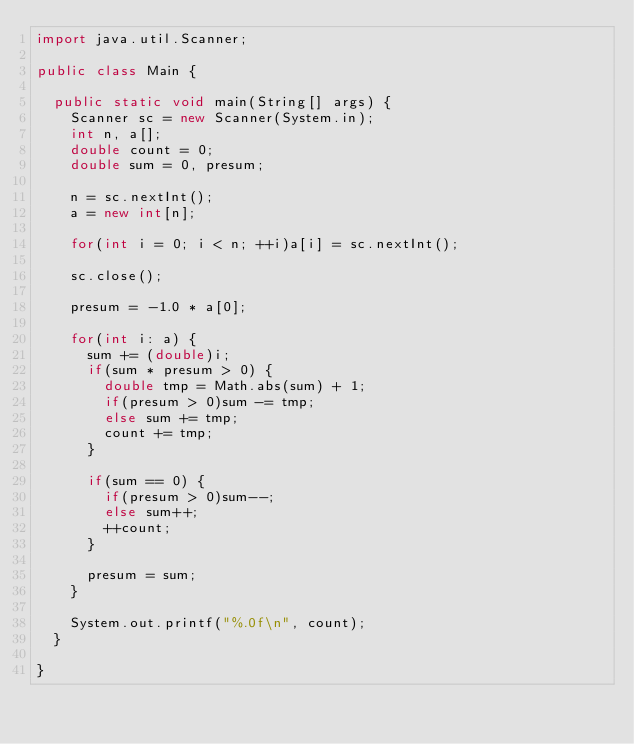Convert code to text. <code><loc_0><loc_0><loc_500><loc_500><_Java_>import java.util.Scanner;

public class Main {

	public static void main(String[] args) {
		Scanner sc = new Scanner(System.in);
		int n, a[];
		double count = 0;
		double sum = 0, presum;
		
		n = sc.nextInt();
		a = new int[n];
		
		for(int i = 0; i < n; ++i)a[i] = sc.nextInt();
		
		sc.close();
		
		presum = -1.0 * a[0];
		
		for(int i: a) {
			sum += (double)i;
			if(sum * presum > 0) {
				double tmp = Math.abs(sum) + 1;
				if(presum > 0)sum -= tmp;
				else sum += tmp;
				count += tmp;
			}
			
			if(sum == 0) {
				if(presum > 0)sum--;
				else sum++;
				++count;
			}
			
			presum = sum;
		}
		
		System.out.printf("%.0f\n", count);
	}

}
</code> 